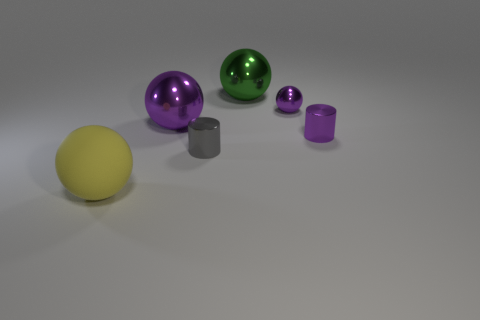What time of day does the lighting in the picture suggest? The lighting in the picture is neutral and diffuse, lacking any strong indication of a specific time of day. It appears to be artificial lighting, typical of an indoor setting, rather than natural sunlight. 